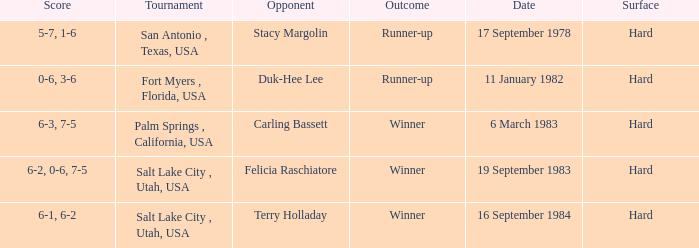What was the score of the match against duk-hee lee? 0-6, 3-6. I'm looking to parse the entire table for insights. Could you assist me with that? {'header': ['Score', 'Tournament', 'Opponent', 'Outcome', 'Date', 'Surface'], 'rows': [['5-7, 1-6', 'San Antonio , Texas, USA', 'Stacy Margolin', 'Runner-up', '17 September 1978', 'Hard'], ['0-6, 3-6', 'Fort Myers , Florida, USA', 'Duk-Hee Lee', 'Runner-up', '11 January 1982', 'Hard'], ['6-3, 7-5', 'Palm Springs , California, USA', 'Carling Bassett', 'Winner', '6 March 1983', 'Hard'], ['6-2, 0-6, 7-5', 'Salt Lake City , Utah, USA', 'Felicia Raschiatore', 'Winner', '19 September 1983', 'Hard'], ['6-1, 6-2', 'Salt Lake City , Utah, USA', 'Terry Holladay', 'Winner', '16 September 1984', 'Hard']]} 